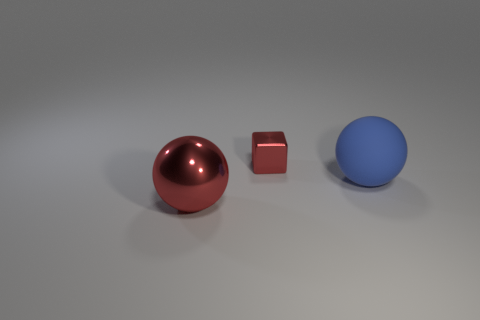If this were a composition in a still life art class, what artistic comments might you share? Approaching this scene as a still life, one might comment on the use of primary colors and basic geometric shapes to create an intriguing composition. The arrangement leaves negative space that balances the image, and the soft lighting accentuates the form of each object without overpowering their individual characteristics. The juxtaposition of the shiny and matte surfaces invites reflection on textures and materiality in art. 